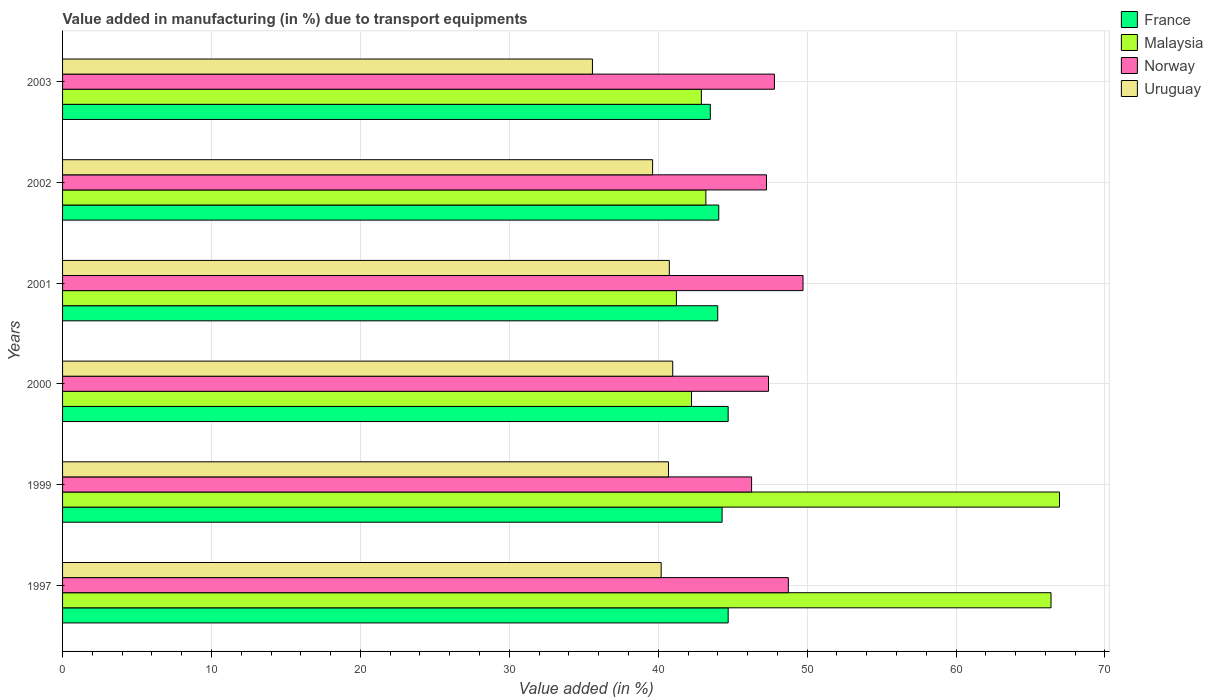How many groups of bars are there?
Ensure brevity in your answer.  6. Are the number of bars on each tick of the Y-axis equal?
Your answer should be very brief. Yes. How many bars are there on the 3rd tick from the bottom?
Your answer should be compact. 4. What is the percentage of value added in manufacturing due to transport equipments in France in 2000?
Your answer should be compact. 44.7. Across all years, what is the maximum percentage of value added in manufacturing due to transport equipments in Uruguay?
Ensure brevity in your answer.  40.97. Across all years, what is the minimum percentage of value added in manufacturing due to transport equipments in France?
Your answer should be very brief. 43.5. In which year was the percentage of value added in manufacturing due to transport equipments in Malaysia minimum?
Ensure brevity in your answer.  2001. What is the total percentage of value added in manufacturing due to transport equipments in Norway in the graph?
Ensure brevity in your answer.  287.21. What is the difference between the percentage of value added in manufacturing due to transport equipments in France in 1999 and that in 2000?
Make the answer very short. -0.41. What is the difference between the percentage of value added in manufacturing due to transport equipments in Norway in 1997 and the percentage of value added in manufacturing due to transport equipments in France in 2001?
Offer a terse response. 4.74. What is the average percentage of value added in manufacturing due to transport equipments in France per year?
Offer a very short reply. 44.21. In the year 1999, what is the difference between the percentage of value added in manufacturing due to transport equipments in Malaysia and percentage of value added in manufacturing due to transport equipments in Norway?
Your answer should be very brief. 20.68. In how many years, is the percentage of value added in manufacturing due to transport equipments in Uruguay greater than 16 %?
Provide a short and direct response. 6. What is the ratio of the percentage of value added in manufacturing due to transport equipments in Norway in 2000 to that in 2002?
Provide a succinct answer. 1. Is the percentage of value added in manufacturing due to transport equipments in Malaysia in 1997 less than that in 2000?
Your response must be concise. No. Is the difference between the percentage of value added in manufacturing due to transport equipments in Malaysia in 1997 and 1999 greater than the difference between the percentage of value added in manufacturing due to transport equipments in Norway in 1997 and 1999?
Give a very brief answer. No. What is the difference between the highest and the second highest percentage of value added in manufacturing due to transport equipments in Malaysia?
Keep it short and to the point. 0.57. What is the difference between the highest and the lowest percentage of value added in manufacturing due to transport equipments in Norway?
Provide a succinct answer. 3.45. Is it the case that in every year, the sum of the percentage of value added in manufacturing due to transport equipments in Uruguay and percentage of value added in manufacturing due to transport equipments in France is greater than the sum of percentage of value added in manufacturing due to transport equipments in Malaysia and percentage of value added in manufacturing due to transport equipments in Norway?
Your answer should be very brief. No. What does the 1st bar from the top in 1997 represents?
Your answer should be compact. Uruguay. What does the 2nd bar from the bottom in 2003 represents?
Provide a short and direct response. Malaysia. How many bars are there?
Provide a short and direct response. 24. How many years are there in the graph?
Your answer should be compact. 6. What is the difference between two consecutive major ticks on the X-axis?
Provide a short and direct response. 10. Does the graph contain any zero values?
Provide a succinct answer. No. How many legend labels are there?
Your answer should be compact. 4. How are the legend labels stacked?
Give a very brief answer. Vertical. What is the title of the graph?
Make the answer very short. Value added in manufacturing (in %) due to transport equipments. What is the label or title of the X-axis?
Provide a succinct answer. Value added (in %). What is the Value added (in %) in France in 1997?
Offer a terse response. 44.7. What is the Value added (in %) in Malaysia in 1997?
Offer a very short reply. 66.38. What is the Value added (in %) of Norway in 1997?
Offer a very short reply. 48.74. What is the Value added (in %) in Uruguay in 1997?
Make the answer very short. 40.2. What is the Value added (in %) of France in 1999?
Make the answer very short. 44.29. What is the Value added (in %) in Malaysia in 1999?
Ensure brevity in your answer.  66.95. What is the Value added (in %) in Norway in 1999?
Provide a succinct answer. 46.27. What is the Value added (in %) in Uruguay in 1999?
Your response must be concise. 40.69. What is the Value added (in %) of France in 2000?
Make the answer very short. 44.7. What is the Value added (in %) in Malaysia in 2000?
Provide a short and direct response. 42.24. What is the Value added (in %) in Norway in 2000?
Provide a succinct answer. 47.4. What is the Value added (in %) in Uruguay in 2000?
Keep it short and to the point. 40.97. What is the Value added (in %) in France in 2001?
Provide a succinct answer. 44. What is the Value added (in %) of Malaysia in 2001?
Provide a short and direct response. 41.22. What is the Value added (in %) in Norway in 2001?
Provide a short and direct response. 49.72. What is the Value added (in %) in Uruguay in 2001?
Offer a very short reply. 40.75. What is the Value added (in %) of France in 2002?
Provide a short and direct response. 44.07. What is the Value added (in %) in Malaysia in 2002?
Make the answer very short. 43.2. What is the Value added (in %) of Norway in 2002?
Keep it short and to the point. 47.27. What is the Value added (in %) of Uruguay in 2002?
Your answer should be very brief. 39.62. What is the Value added (in %) in France in 2003?
Give a very brief answer. 43.5. What is the Value added (in %) of Malaysia in 2003?
Ensure brevity in your answer.  42.9. What is the Value added (in %) of Norway in 2003?
Provide a succinct answer. 47.8. What is the Value added (in %) of Uruguay in 2003?
Your answer should be compact. 35.58. Across all years, what is the maximum Value added (in %) in France?
Provide a succinct answer. 44.7. Across all years, what is the maximum Value added (in %) in Malaysia?
Provide a short and direct response. 66.95. Across all years, what is the maximum Value added (in %) in Norway?
Keep it short and to the point. 49.72. Across all years, what is the maximum Value added (in %) in Uruguay?
Make the answer very short. 40.97. Across all years, what is the minimum Value added (in %) in France?
Provide a succinct answer. 43.5. Across all years, what is the minimum Value added (in %) in Malaysia?
Give a very brief answer. 41.22. Across all years, what is the minimum Value added (in %) of Norway?
Your answer should be compact. 46.27. Across all years, what is the minimum Value added (in %) in Uruguay?
Provide a succinct answer. 35.58. What is the total Value added (in %) in France in the graph?
Provide a short and direct response. 265.25. What is the total Value added (in %) in Malaysia in the graph?
Make the answer very short. 302.88. What is the total Value added (in %) of Norway in the graph?
Offer a very short reply. 287.21. What is the total Value added (in %) in Uruguay in the graph?
Your answer should be compact. 237.81. What is the difference between the Value added (in %) of France in 1997 and that in 1999?
Provide a short and direct response. 0.41. What is the difference between the Value added (in %) in Malaysia in 1997 and that in 1999?
Your response must be concise. -0.57. What is the difference between the Value added (in %) in Norway in 1997 and that in 1999?
Offer a very short reply. 2.47. What is the difference between the Value added (in %) of Uruguay in 1997 and that in 1999?
Ensure brevity in your answer.  -0.49. What is the difference between the Value added (in %) of France in 1997 and that in 2000?
Your answer should be compact. 0. What is the difference between the Value added (in %) of Malaysia in 1997 and that in 2000?
Your answer should be compact. 24.14. What is the difference between the Value added (in %) in Norway in 1997 and that in 2000?
Ensure brevity in your answer.  1.33. What is the difference between the Value added (in %) in Uruguay in 1997 and that in 2000?
Make the answer very short. -0.78. What is the difference between the Value added (in %) of France in 1997 and that in 2001?
Ensure brevity in your answer.  0.7. What is the difference between the Value added (in %) in Malaysia in 1997 and that in 2001?
Make the answer very short. 25.16. What is the difference between the Value added (in %) of Norway in 1997 and that in 2001?
Give a very brief answer. -0.99. What is the difference between the Value added (in %) in Uruguay in 1997 and that in 2001?
Ensure brevity in your answer.  -0.55. What is the difference between the Value added (in %) of France in 1997 and that in 2002?
Provide a succinct answer. 0.63. What is the difference between the Value added (in %) in Malaysia in 1997 and that in 2002?
Make the answer very short. 23.18. What is the difference between the Value added (in %) of Norway in 1997 and that in 2002?
Your answer should be very brief. 1.47. What is the difference between the Value added (in %) of Uruguay in 1997 and that in 2002?
Your answer should be very brief. 0.58. What is the difference between the Value added (in %) in France in 1997 and that in 2003?
Your response must be concise. 1.2. What is the difference between the Value added (in %) of Malaysia in 1997 and that in 2003?
Keep it short and to the point. 23.48. What is the difference between the Value added (in %) in Norway in 1997 and that in 2003?
Offer a terse response. 0.94. What is the difference between the Value added (in %) of Uruguay in 1997 and that in 2003?
Keep it short and to the point. 4.62. What is the difference between the Value added (in %) in France in 1999 and that in 2000?
Offer a terse response. -0.41. What is the difference between the Value added (in %) in Malaysia in 1999 and that in 2000?
Offer a terse response. 24.71. What is the difference between the Value added (in %) of Norway in 1999 and that in 2000?
Make the answer very short. -1.13. What is the difference between the Value added (in %) in Uruguay in 1999 and that in 2000?
Provide a succinct answer. -0.29. What is the difference between the Value added (in %) of France in 1999 and that in 2001?
Make the answer very short. 0.29. What is the difference between the Value added (in %) in Malaysia in 1999 and that in 2001?
Offer a terse response. 25.73. What is the difference between the Value added (in %) of Norway in 1999 and that in 2001?
Your response must be concise. -3.45. What is the difference between the Value added (in %) in Uruguay in 1999 and that in 2001?
Make the answer very short. -0.06. What is the difference between the Value added (in %) in France in 1999 and that in 2002?
Provide a short and direct response. 0.22. What is the difference between the Value added (in %) in Malaysia in 1999 and that in 2002?
Keep it short and to the point. 23.75. What is the difference between the Value added (in %) of Norway in 1999 and that in 2002?
Provide a short and direct response. -1. What is the difference between the Value added (in %) in Uruguay in 1999 and that in 2002?
Ensure brevity in your answer.  1.07. What is the difference between the Value added (in %) in France in 1999 and that in 2003?
Your answer should be very brief. 0.79. What is the difference between the Value added (in %) of Malaysia in 1999 and that in 2003?
Offer a terse response. 24.05. What is the difference between the Value added (in %) of Norway in 1999 and that in 2003?
Your response must be concise. -1.53. What is the difference between the Value added (in %) of Uruguay in 1999 and that in 2003?
Offer a very short reply. 5.11. What is the difference between the Value added (in %) in France in 2000 and that in 2001?
Your response must be concise. 0.7. What is the difference between the Value added (in %) of Malaysia in 2000 and that in 2001?
Your answer should be very brief. 1.02. What is the difference between the Value added (in %) in Norway in 2000 and that in 2001?
Offer a terse response. -2.32. What is the difference between the Value added (in %) in Uruguay in 2000 and that in 2001?
Provide a short and direct response. 0.23. What is the difference between the Value added (in %) in France in 2000 and that in 2002?
Offer a terse response. 0.63. What is the difference between the Value added (in %) in Malaysia in 2000 and that in 2002?
Offer a terse response. -0.96. What is the difference between the Value added (in %) in Norway in 2000 and that in 2002?
Your answer should be very brief. 0.13. What is the difference between the Value added (in %) in Uruguay in 2000 and that in 2002?
Your answer should be compact. 1.35. What is the difference between the Value added (in %) of France in 2000 and that in 2003?
Your response must be concise. 1.2. What is the difference between the Value added (in %) in Malaysia in 2000 and that in 2003?
Ensure brevity in your answer.  -0.66. What is the difference between the Value added (in %) of Norway in 2000 and that in 2003?
Offer a terse response. -0.4. What is the difference between the Value added (in %) in Uruguay in 2000 and that in 2003?
Offer a terse response. 5.39. What is the difference between the Value added (in %) of France in 2001 and that in 2002?
Provide a short and direct response. -0.07. What is the difference between the Value added (in %) in Malaysia in 2001 and that in 2002?
Ensure brevity in your answer.  -1.98. What is the difference between the Value added (in %) of Norway in 2001 and that in 2002?
Your response must be concise. 2.45. What is the difference between the Value added (in %) in Uruguay in 2001 and that in 2002?
Provide a succinct answer. 1.12. What is the difference between the Value added (in %) in France in 2001 and that in 2003?
Make the answer very short. 0.5. What is the difference between the Value added (in %) of Malaysia in 2001 and that in 2003?
Make the answer very short. -1.68. What is the difference between the Value added (in %) of Norway in 2001 and that in 2003?
Ensure brevity in your answer.  1.92. What is the difference between the Value added (in %) of Uruguay in 2001 and that in 2003?
Provide a short and direct response. 5.16. What is the difference between the Value added (in %) in France in 2002 and that in 2003?
Your response must be concise. 0.57. What is the difference between the Value added (in %) of Malaysia in 2002 and that in 2003?
Your response must be concise. 0.3. What is the difference between the Value added (in %) in Norway in 2002 and that in 2003?
Make the answer very short. -0.53. What is the difference between the Value added (in %) of Uruguay in 2002 and that in 2003?
Give a very brief answer. 4.04. What is the difference between the Value added (in %) of France in 1997 and the Value added (in %) of Malaysia in 1999?
Offer a very short reply. -22.25. What is the difference between the Value added (in %) in France in 1997 and the Value added (in %) in Norway in 1999?
Ensure brevity in your answer.  -1.57. What is the difference between the Value added (in %) of France in 1997 and the Value added (in %) of Uruguay in 1999?
Keep it short and to the point. 4.01. What is the difference between the Value added (in %) of Malaysia in 1997 and the Value added (in %) of Norway in 1999?
Your answer should be compact. 20.11. What is the difference between the Value added (in %) in Malaysia in 1997 and the Value added (in %) in Uruguay in 1999?
Your answer should be very brief. 25.69. What is the difference between the Value added (in %) in Norway in 1997 and the Value added (in %) in Uruguay in 1999?
Ensure brevity in your answer.  8.05. What is the difference between the Value added (in %) in France in 1997 and the Value added (in %) in Malaysia in 2000?
Offer a terse response. 2.46. What is the difference between the Value added (in %) of France in 1997 and the Value added (in %) of Norway in 2000?
Ensure brevity in your answer.  -2.71. What is the difference between the Value added (in %) of France in 1997 and the Value added (in %) of Uruguay in 2000?
Ensure brevity in your answer.  3.72. What is the difference between the Value added (in %) in Malaysia in 1997 and the Value added (in %) in Norway in 2000?
Your answer should be very brief. 18.97. What is the difference between the Value added (in %) of Malaysia in 1997 and the Value added (in %) of Uruguay in 2000?
Make the answer very short. 25.4. What is the difference between the Value added (in %) of Norway in 1997 and the Value added (in %) of Uruguay in 2000?
Provide a succinct answer. 7.76. What is the difference between the Value added (in %) in France in 1997 and the Value added (in %) in Malaysia in 2001?
Ensure brevity in your answer.  3.48. What is the difference between the Value added (in %) in France in 1997 and the Value added (in %) in Norway in 2001?
Make the answer very short. -5.03. What is the difference between the Value added (in %) in France in 1997 and the Value added (in %) in Uruguay in 2001?
Make the answer very short. 3.95. What is the difference between the Value added (in %) of Malaysia in 1997 and the Value added (in %) of Norway in 2001?
Keep it short and to the point. 16.65. What is the difference between the Value added (in %) of Malaysia in 1997 and the Value added (in %) of Uruguay in 2001?
Provide a short and direct response. 25.63. What is the difference between the Value added (in %) of Norway in 1997 and the Value added (in %) of Uruguay in 2001?
Your answer should be very brief. 7.99. What is the difference between the Value added (in %) in France in 1997 and the Value added (in %) in Malaysia in 2002?
Offer a very short reply. 1.5. What is the difference between the Value added (in %) of France in 1997 and the Value added (in %) of Norway in 2002?
Offer a terse response. -2.57. What is the difference between the Value added (in %) in France in 1997 and the Value added (in %) in Uruguay in 2002?
Provide a succinct answer. 5.07. What is the difference between the Value added (in %) in Malaysia in 1997 and the Value added (in %) in Norway in 2002?
Provide a short and direct response. 19.11. What is the difference between the Value added (in %) of Malaysia in 1997 and the Value added (in %) of Uruguay in 2002?
Keep it short and to the point. 26.75. What is the difference between the Value added (in %) in Norway in 1997 and the Value added (in %) in Uruguay in 2002?
Give a very brief answer. 9.12. What is the difference between the Value added (in %) in France in 1997 and the Value added (in %) in Malaysia in 2003?
Offer a very short reply. 1.8. What is the difference between the Value added (in %) in France in 1997 and the Value added (in %) in Norway in 2003?
Your answer should be very brief. -3.11. What is the difference between the Value added (in %) of France in 1997 and the Value added (in %) of Uruguay in 2003?
Make the answer very short. 9.12. What is the difference between the Value added (in %) of Malaysia in 1997 and the Value added (in %) of Norway in 2003?
Ensure brevity in your answer.  18.57. What is the difference between the Value added (in %) of Malaysia in 1997 and the Value added (in %) of Uruguay in 2003?
Offer a very short reply. 30.79. What is the difference between the Value added (in %) of Norway in 1997 and the Value added (in %) of Uruguay in 2003?
Ensure brevity in your answer.  13.16. What is the difference between the Value added (in %) of France in 1999 and the Value added (in %) of Malaysia in 2000?
Offer a terse response. 2.05. What is the difference between the Value added (in %) in France in 1999 and the Value added (in %) in Norway in 2000?
Give a very brief answer. -3.11. What is the difference between the Value added (in %) in France in 1999 and the Value added (in %) in Uruguay in 2000?
Provide a short and direct response. 3.32. What is the difference between the Value added (in %) in Malaysia in 1999 and the Value added (in %) in Norway in 2000?
Offer a terse response. 19.54. What is the difference between the Value added (in %) in Malaysia in 1999 and the Value added (in %) in Uruguay in 2000?
Make the answer very short. 25.97. What is the difference between the Value added (in %) of Norway in 1999 and the Value added (in %) of Uruguay in 2000?
Your response must be concise. 5.3. What is the difference between the Value added (in %) in France in 1999 and the Value added (in %) in Malaysia in 2001?
Keep it short and to the point. 3.07. What is the difference between the Value added (in %) in France in 1999 and the Value added (in %) in Norway in 2001?
Your answer should be very brief. -5.43. What is the difference between the Value added (in %) of France in 1999 and the Value added (in %) of Uruguay in 2001?
Provide a short and direct response. 3.54. What is the difference between the Value added (in %) of Malaysia in 1999 and the Value added (in %) of Norway in 2001?
Keep it short and to the point. 17.22. What is the difference between the Value added (in %) in Malaysia in 1999 and the Value added (in %) in Uruguay in 2001?
Make the answer very short. 26.2. What is the difference between the Value added (in %) of Norway in 1999 and the Value added (in %) of Uruguay in 2001?
Make the answer very short. 5.52. What is the difference between the Value added (in %) in France in 1999 and the Value added (in %) in Malaysia in 2002?
Provide a succinct answer. 1.09. What is the difference between the Value added (in %) in France in 1999 and the Value added (in %) in Norway in 2002?
Your answer should be compact. -2.98. What is the difference between the Value added (in %) in France in 1999 and the Value added (in %) in Uruguay in 2002?
Your response must be concise. 4.67. What is the difference between the Value added (in %) in Malaysia in 1999 and the Value added (in %) in Norway in 2002?
Your response must be concise. 19.68. What is the difference between the Value added (in %) in Malaysia in 1999 and the Value added (in %) in Uruguay in 2002?
Your answer should be compact. 27.33. What is the difference between the Value added (in %) of Norway in 1999 and the Value added (in %) of Uruguay in 2002?
Ensure brevity in your answer.  6.65. What is the difference between the Value added (in %) of France in 1999 and the Value added (in %) of Malaysia in 2003?
Offer a terse response. 1.39. What is the difference between the Value added (in %) in France in 1999 and the Value added (in %) in Norway in 2003?
Give a very brief answer. -3.51. What is the difference between the Value added (in %) in France in 1999 and the Value added (in %) in Uruguay in 2003?
Your answer should be compact. 8.71. What is the difference between the Value added (in %) of Malaysia in 1999 and the Value added (in %) of Norway in 2003?
Give a very brief answer. 19.15. What is the difference between the Value added (in %) in Malaysia in 1999 and the Value added (in %) in Uruguay in 2003?
Your answer should be compact. 31.37. What is the difference between the Value added (in %) in Norway in 1999 and the Value added (in %) in Uruguay in 2003?
Your response must be concise. 10.69. What is the difference between the Value added (in %) of France in 2000 and the Value added (in %) of Malaysia in 2001?
Your answer should be very brief. 3.48. What is the difference between the Value added (in %) of France in 2000 and the Value added (in %) of Norway in 2001?
Provide a short and direct response. -5.03. What is the difference between the Value added (in %) in France in 2000 and the Value added (in %) in Uruguay in 2001?
Ensure brevity in your answer.  3.95. What is the difference between the Value added (in %) in Malaysia in 2000 and the Value added (in %) in Norway in 2001?
Your answer should be very brief. -7.49. What is the difference between the Value added (in %) in Malaysia in 2000 and the Value added (in %) in Uruguay in 2001?
Provide a short and direct response. 1.49. What is the difference between the Value added (in %) of Norway in 2000 and the Value added (in %) of Uruguay in 2001?
Your answer should be compact. 6.66. What is the difference between the Value added (in %) in France in 2000 and the Value added (in %) in Malaysia in 2002?
Provide a succinct answer. 1.5. What is the difference between the Value added (in %) in France in 2000 and the Value added (in %) in Norway in 2002?
Your response must be concise. -2.57. What is the difference between the Value added (in %) of France in 2000 and the Value added (in %) of Uruguay in 2002?
Your answer should be very brief. 5.07. What is the difference between the Value added (in %) of Malaysia in 2000 and the Value added (in %) of Norway in 2002?
Offer a very short reply. -5.03. What is the difference between the Value added (in %) in Malaysia in 2000 and the Value added (in %) in Uruguay in 2002?
Your answer should be compact. 2.61. What is the difference between the Value added (in %) in Norway in 2000 and the Value added (in %) in Uruguay in 2002?
Keep it short and to the point. 7.78. What is the difference between the Value added (in %) in France in 2000 and the Value added (in %) in Malaysia in 2003?
Make the answer very short. 1.8. What is the difference between the Value added (in %) in France in 2000 and the Value added (in %) in Norway in 2003?
Your response must be concise. -3.11. What is the difference between the Value added (in %) of France in 2000 and the Value added (in %) of Uruguay in 2003?
Your response must be concise. 9.11. What is the difference between the Value added (in %) of Malaysia in 2000 and the Value added (in %) of Norway in 2003?
Keep it short and to the point. -5.57. What is the difference between the Value added (in %) of Malaysia in 2000 and the Value added (in %) of Uruguay in 2003?
Give a very brief answer. 6.65. What is the difference between the Value added (in %) in Norway in 2000 and the Value added (in %) in Uruguay in 2003?
Provide a succinct answer. 11.82. What is the difference between the Value added (in %) of France in 2001 and the Value added (in %) of Malaysia in 2002?
Your response must be concise. 0.8. What is the difference between the Value added (in %) in France in 2001 and the Value added (in %) in Norway in 2002?
Provide a short and direct response. -3.27. What is the difference between the Value added (in %) of France in 2001 and the Value added (in %) of Uruguay in 2002?
Your response must be concise. 4.37. What is the difference between the Value added (in %) in Malaysia in 2001 and the Value added (in %) in Norway in 2002?
Make the answer very short. -6.05. What is the difference between the Value added (in %) in Malaysia in 2001 and the Value added (in %) in Uruguay in 2002?
Your answer should be compact. 1.6. What is the difference between the Value added (in %) of Norway in 2001 and the Value added (in %) of Uruguay in 2002?
Your answer should be compact. 10.1. What is the difference between the Value added (in %) in France in 2001 and the Value added (in %) in Malaysia in 2003?
Your response must be concise. 1.1. What is the difference between the Value added (in %) in France in 2001 and the Value added (in %) in Norway in 2003?
Give a very brief answer. -3.81. What is the difference between the Value added (in %) of France in 2001 and the Value added (in %) of Uruguay in 2003?
Your answer should be compact. 8.41. What is the difference between the Value added (in %) in Malaysia in 2001 and the Value added (in %) in Norway in 2003?
Your answer should be very brief. -6.58. What is the difference between the Value added (in %) in Malaysia in 2001 and the Value added (in %) in Uruguay in 2003?
Offer a terse response. 5.64. What is the difference between the Value added (in %) of Norway in 2001 and the Value added (in %) of Uruguay in 2003?
Your response must be concise. 14.14. What is the difference between the Value added (in %) of France in 2002 and the Value added (in %) of Malaysia in 2003?
Ensure brevity in your answer.  1.17. What is the difference between the Value added (in %) of France in 2002 and the Value added (in %) of Norway in 2003?
Your answer should be very brief. -3.74. What is the difference between the Value added (in %) of France in 2002 and the Value added (in %) of Uruguay in 2003?
Your answer should be compact. 8.48. What is the difference between the Value added (in %) of Malaysia in 2002 and the Value added (in %) of Norway in 2003?
Give a very brief answer. -4.6. What is the difference between the Value added (in %) in Malaysia in 2002 and the Value added (in %) in Uruguay in 2003?
Your response must be concise. 7.62. What is the difference between the Value added (in %) of Norway in 2002 and the Value added (in %) of Uruguay in 2003?
Give a very brief answer. 11.69. What is the average Value added (in %) of France per year?
Give a very brief answer. 44.21. What is the average Value added (in %) of Malaysia per year?
Your response must be concise. 50.48. What is the average Value added (in %) of Norway per year?
Your answer should be very brief. 47.87. What is the average Value added (in %) in Uruguay per year?
Your response must be concise. 39.64. In the year 1997, what is the difference between the Value added (in %) of France and Value added (in %) of Malaysia?
Your answer should be compact. -21.68. In the year 1997, what is the difference between the Value added (in %) in France and Value added (in %) in Norway?
Your response must be concise. -4.04. In the year 1997, what is the difference between the Value added (in %) in France and Value added (in %) in Uruguay?
Make the answer very short. 4.5. In the year 1997, what is the difference between the Value added (in %) in Malaysia and Value added (in %) in Norway?
Give a very brief answer. 17.64. In the year 1997, what is the difference between the Value added (in %) of Malaysia and Value added (in %) of Uruguay?
Give a very brief answer. 26.18. In the year 1997, what is the difference between the Value added (in %) of Norway and Value added (in %) of Uruguay?
Make the answer very short. 8.54. In the year 1999, what is the difference between the Value added (in %) in France and Value added (in %) in Malaysia?
Make the answer very short. -22.66. In the year 1999, what is the difference between the Value added (in %) in France and Value added (in %) in Norway?
Offer a terse response. -1.98. In the year 1999, what is the difference between the Value added (in %) of France and Value added (in %) of Uruguay?
Ensure brevity in your answer.  3.6. In the year 1999, what is the difference between the Value added (in %) in Malaysia and Value added (in %) in Norway?
Your response must be concise. 20.68. In the year 1999, what is the difference between the Value added (in %) in Malaysia and Value added (in %) in Uruguay?
Your answer should be compact. 26.26. In the year 1999, what is the difference between the Value added (in %) in Norway and Value added (in %) in Uruguay?
Keep it short and to the point. 5.58. In the year 2000, what is the difference between the Value added (in %) in France and Value added (in %) in Malaysia?
Give a very brief answer. 2.46. In the year 2000, what is the difference between the Value added (in %) of France and Value added (in %) of Norway?
Your answer should be compact. -2.71. In the year 2000, what is the difference between the Value added (in %) in France and Value added (in %) in Uruguay?
Offer a terse response. 3.72. In the year 2000, what is the difference between the Value added (in %) of Malaysia and Value added (in %) of Norway?
Your answer should be very brief. -5.17. In the year 2000, what is the difference between the Value added (in %) of Malaysia and Value added (in %) of Uruguay?
Ensure brevity in your answer.  1.26. In the year 2000, what is the difference between the Value added (in %) of Norway and Value added (in %) of Uruguay?
Provide a succinct answer. 6.43. In the year 2001, what is the difference between the Value added (in %) in France and Value added (in %) in Malaysia?
Provide a short and direct response. 2.78. In the year 2001, what is the difference between the Value added (in %) of France and Value added (in %) of Norway?
Offer a very short reply. -5.73. In the year 2001, what is the difference between the Value added (in %) in France and Value added (in %) in Uruguay?
Offer a terse response. 3.25. In the year 2001, what is the difference between the Value added (in %) in Malaysia and Value added (in %) in Norway?
Provide a succinct answer. -8.5. In the year 2001, what is the difference between the Value added (in %) in Malaysia and Value added (in %) in Uruguay?
Provide a short and direct response. 0.47. In the year 2001, what is the difference between the Value added (in %) of Norway and Value added (in %) of Uruguay?
Provide a succinct answer. 8.98. In the year 2002, what is the difference between the Value added (in %) of France and Value added (in %) of Malaysia?
Keep it short and to the point. 0.87. In the year 2002, what is the difference between the Value added (in %) in France and Value added (in %) in Norway?
Offer a very short reply. -3.21. In the year 2002, what is the difference between the Value added (in %) in France and Value added (in %) in Uruguay?
Your response must be concise. 4.44. In the year 2002, what is the difference between the Value added (in %) of Malaysia and Value added (in %) of Norway?
Provide a succinct answer. -4.07. In the year 2002, what is the difference between the Value added (in %) in Malaysia and Value added (in %) in Uruguay?
Provide a succinct answer. 3.58. In the year 2002, what is the difference between the Value added (in %) of Norway and Value added (in %) of Uruguay?
Offer a terse response. 7.65. In the year 2003, what is the difference between the Value added (in %) in France and Value added (in %) in Malaysia?
Ensure brevity in your answer.  0.6. In the year 2003, what is the difference between the Value added (in %) in France and Value added (in %) in Norway?
Provide a short and direct response. -4.3. In the year 2003, what is the difference between the Value added (in %) in France and Value added (in %) in Uruguay?
Make the answer very short. 7.92. In the year 2003, what is the difference between the Value added (in %) of Malaysia and Value added (in %) of Norway?
Offer a terse response. -4.9. In the year 2003, what is the difference between the Value added (in %) in Malaysia and Value added (in %) in Uruguay?
Provide a short and direct response. 7.32. In the year 2003, what is the difference between the Value added (in %) in Norway and Value added (in %) in Uruguay?
Make the answer very short. 12.22. What is the ratio of the Value added (in %) of France in 1997 to that in 1999?
Your answer should be compact. 1.01. What is the ratio of the Value added (in %) of Norway in 1997 to that in 1999?
Keep it short and to the point. 1.05. What is the ratio of the Value added (in %) in Uruguay in 1997 to that in 1999?
Ensure brevity in your answer.  0.99. What is the ratio of the Value added (in %) of Malaysia in 1997 to that in 2000?
Your response must be concise. 1.57. What is the ratio of the Value added (in %) in Norway in 1997 to that in 2000?
Make the answer very short. 1.03. What is the ratio of the Value added (in %) in Uruguay in 1997 to that in 2000?
Give a very brief answer. 0.98. What is the ratio of the Value added (in %) in France in 1997 to that in 2001?
Provide a succinct answer. 1.02. What is the ratio of the Value added (in %) in Malaysia in 1997 to that in 2001?
Your response must be concise. 1.61. What is the ratio of the Value added (in %) in Norway in 1997 to that in 2001?
Ensure brevity in your answer.  0.98. What is the ratio of the Value added (in %) in Uruguay in 1997 to that in 2001?
Your answer should be compact. 0.99. What is the ratio of the Value added (in %) of France in 1997 to that in 2002?
Your answer should be compact. 1.01. What is the ratio of the Value added (in %) of Malaysia in 1997 to that in 2002?
Ensure brevity in your answer.  1.54. What is the ratio of the Value added (in %) of Norway in 1997 to that in 2002?
Your response must be concise. 1.03. What is the ratio of the Value added (in %) of Uruguay in 1997 to that in 2002?
Ensure brevity in your answer.  1.01. What is the ratio of the Value added (in %) of France in 1997 to that in 2003?
Offer a terse response. 1.03. What is the ratio of the Value added (in %) of Malaysia in 1997 to that in 2003?
Provide a succinct answer. 1.55. What is the ratio of the Value added (in %) in Norway in 1997 to that in 2003?
Offer a terse response. 1.02. What is the ratio of the Value added (in %) in Uruguay in 1997 to that in 2003?
Ensure brevity in your answer.  1.13. What is the ratio of the Value added (in %) in France in 1999 to that in 2000?
Your response must be concise. 0.99. What is the ratio of the Value added (in %) in Malaysia in 1999 to that in 2000?
Your response must be concise. 1.59. What is the ratio of the Value added (in %) in Norway in 1999 to that in 2000?
Give a very brief answer. 0.98. What is the ratio of the Value added (in %) of France in 1999 to that in 2001?
Keep it short and to the point. 1.01. What is the ratio of the Value added (in %) in Malaysia in 1999 to that in 2001?
Provide a short and direct response. 1.62. What is the ratio of the Value added (in %) in Norway in 1999 to that in 2001?
Your response must be concise. 0.93. What is the ratio of the Value added (in %) of Uruguay in 1999 to that in 2001?
Make the answer very short. 1. What is the ratio of the Value added (in %) in France in 1999 to that in 2002?
Provide a short and direct response. 1.01. What is the ratio of the Value added (in %) of Malaysia in 1999 to that in 2002?
Make the answer very short. 1.55. What is the ratio of the Value added (in %) in Norway in 1999 to that in 2002?
Provide a short and direct response. 0.98. What is the ratio of the Value added (in %) in Uruguay in 1999 to that in 2002?
Provide a succinct answer. 1.03. What is the ratio of the Value added (in %) in France in 1999 to that in 2003?
Ensure brevity in your answer.  1.02. What is the ratio of the Value added (in %) of Malaysia in 1999 to that in 2003?
Keep it short and to the point. 1.56. What is the ratio of the Value added (in %) in Norway in 1999 to that in 2003?
Offer a terse response. 0.97. What is the ratio of the Value added (in %) in Uruguay in 1999 to that in 2003?
Provide a succinct answer. 1.14. What is the ratio of the Value added (in %) in France in 2000 to that in 2001?
Provide a succinct answer. 1.02. What is the ratio of the Value added (in %) of Malaysia in 2000 to that in 2001?
Keep it short and to the point. 1.02. What is the ratio of the Value added (in %) of Norway in 2000 to that in 2001?
Your answer should be very brief. 0.95. What is the ratio of the Value added (in %) of Uruguay in 2000 to that in 2001?
Offer a very short reply. 1.01. What is the ratio of the Value added (in %) of France in 2000 to that in 2002?
Keep it short and to the point. 1.01. What is the ratio of the Value added (in %) in Malaysia in 2000 to that in 2002?
Ensure brevity in your answer.  0.98. What is the ratio of the Value added (in %) in Norway in 2000 to that in 2002?
Make the answer very short. 1. What is the ratio of the Value added (in %) in Uruguay in 2000 to that in 2002?
Make the answer very short. 1.03. What is the ratio of the Value added (in %) of France in 2000 to that in 2003?
Keep it short and to the point. 1.03. What is the ratio of the Value added (in %) in Malaysia in 2000 to that in 2003?
Provide a succinct answer. 0.98. What is the ratio of the Value added (in %) of Norway in 2000 to that in 2003?
Your answer should be very brief. 0.99. What is the ratio of the Value added (in %) in Uruguay in 2000 to that in 2003?
Your response must be concise. 1.15. What is the ratio of the Value added (in %) in France in 2001 to that in 2002?
Provide a succinct answer. 1. What is the ratio of the Value added (in %) of Malaysia in 2001 to that in 2002?
Provide a short and direct response. 0.95. What is the ratio of the Value added (in %) in Norway in 2001 to that in 2002?
Ensure brevity in your answer.  1.05. What is the ratio of the Value added (in %) of Uruguay in 2001 to that in 2002?
Your answer should be very brief. 1.03. What is the ratio of the Value added (in %) of France in 2001 to that in 2003?
Make the answer very short. 1.01. What is the ratio of the Value added (in %) of Malaysia in 2001 to that in 2003?
Your answer should be compact. 0.96. What is the ratio of the Value added (in %) in Norway in 2001 to that in 2003?
Offer a very short reply. 1.04. What is the ratio of the Value added (in %) of Uruguay in 2001 to that in 2003?
Your answer should be very brief. 1.15. What is the ratio of the Value added (in %) of Norway in 2002 to that in 2003?
Ensure brevity in your answer.  0.99. What is the ratio of the Value added (in %) of Uruguay in 2002 to that in 2003?
Offer a terse response. 1.11. What is the difference between the highest and the second highest Value added (in %) in France?
Keep it short and to the point. 0. What is the difference between the highest and the second highest Value added (in %) in Malaysia?
Offer a very short reply. 0.57. What is the difference between the highest and the second highest Value added (in %) of Norway?
Your answer should be compact. 0.99. What is the difference between the highest and the second highest Value added (in %) of Uruguay?
Ensure brevity in your answer.  0.23. What is the difference between the highest and the lowest Value added (in %) of France?
Ensure brevity in your answer.  1.2. What is the difference between the highest and the lowest Value added (in %) in Malaysia?
Offer a very short reply. 25.73. What is the difference between the highest and the lowest Value added (in %) of Norway?
Offer a very short reply. 3.45. What is the difference between the highest and the lowest Value added (in %) of Uruguay?
Keep it short and to the point. 5.39. 